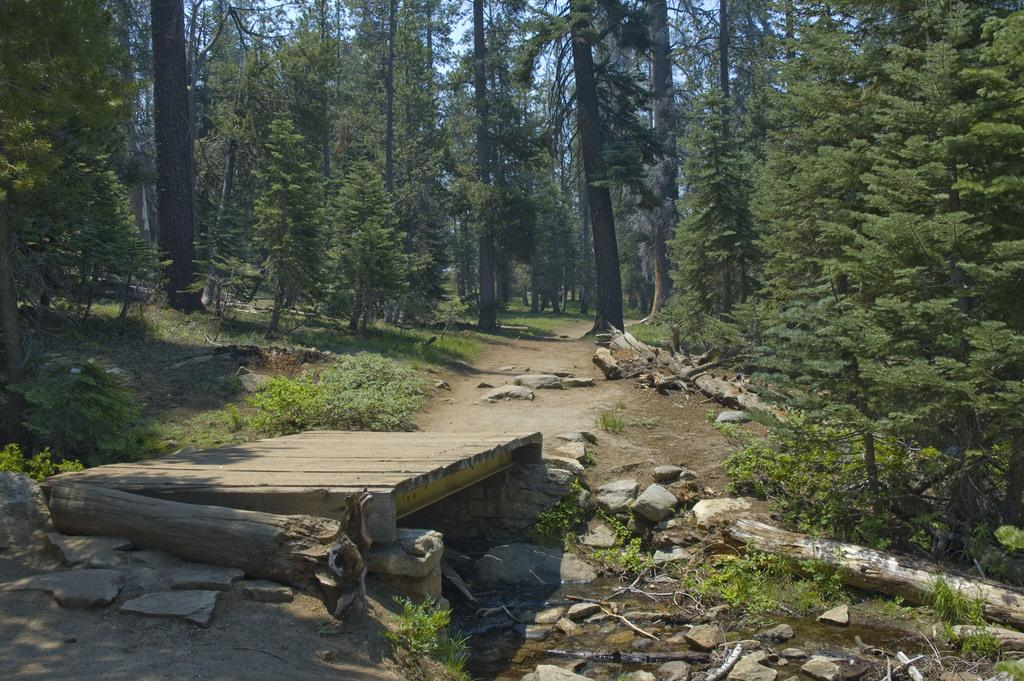What type of bridge is in the image? There is a wooden plank bridge in the image. What is the bridge positioned over? The bridge is over water. What can be seen in the background of the image? There are rocks, wooden logs, trees, and plants in the background of the image. What type of pancake is being served on the wooden plank bridge in the image? There is no pancake present in the image; it is a wooden plank bridge over water with a background of rocks, wooden logs, trees, and plants. 